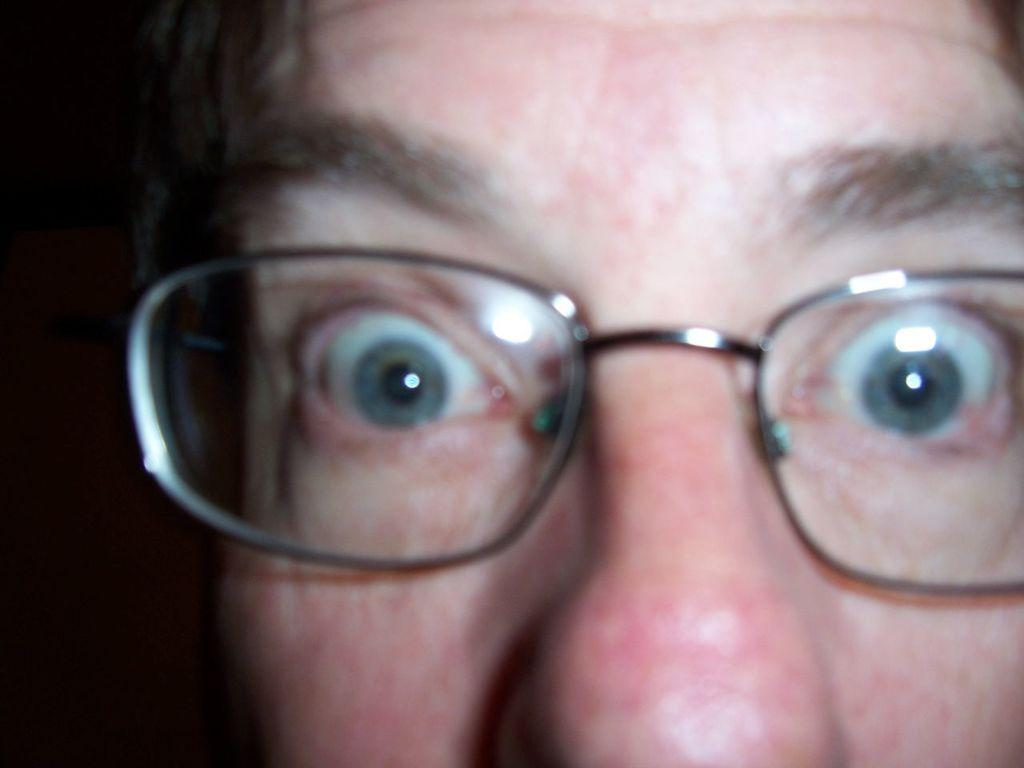What is the main subject of the image? The main subject of the image is the face of a person. What can be seen on the person's face? The person is wearing spectacles. What type of ball is being agreed upon in the image? There is no ball or agreement present in the image; it only features the face of a person wearing spectacles. 